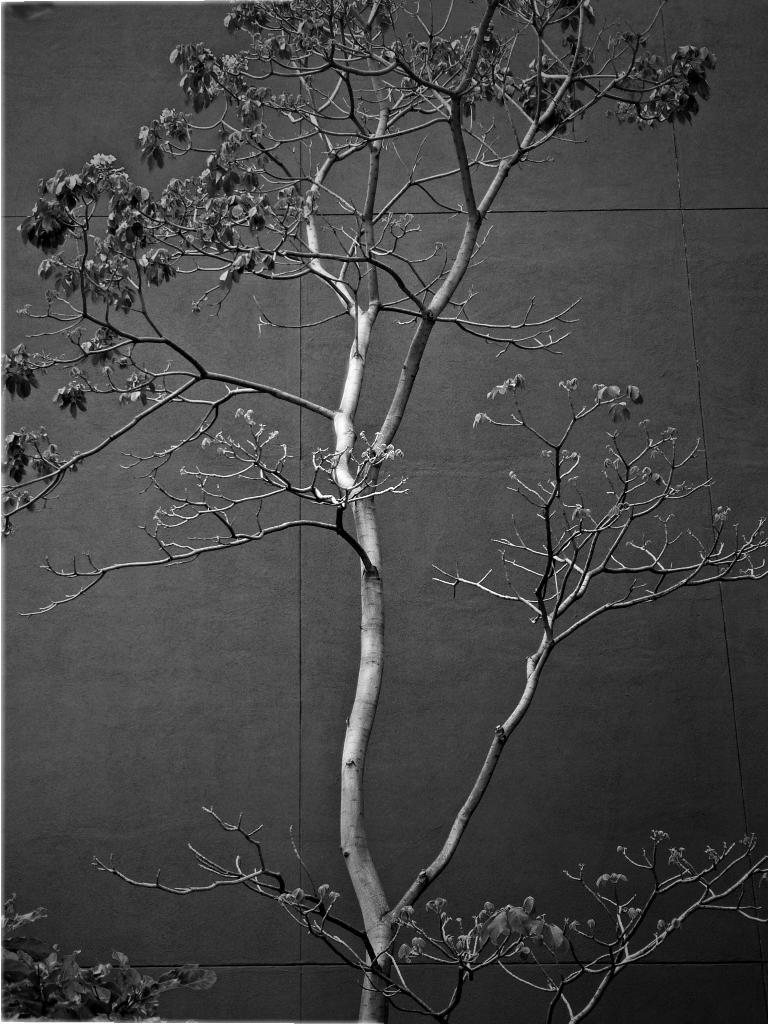What is present in the image? There is a plant in the image. What can be seen in the background of the image? There is a wall in the background of the image. How many dolls are sitting on the stem of the plant in the image? There are no dolls present in the image, and the plant does not have a stem. 